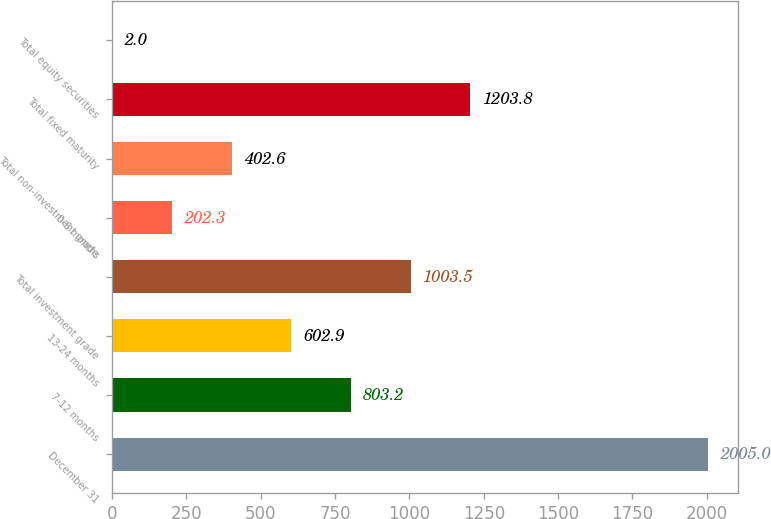<chart> <loc_0><loc_0><loc_500><loc_500><bar_chart><fcel>December 31<fcel>7-12 months<fcel>13-24 months<fcel>Total investment grade<fcel>0-6 months<fcel>Total non-investment grade<fcel>Total fixed maturity<fcel>Total equity securities<nl><fcel>2005<fcel>803.2<fcel>602.9<fcel>1003.5<fcel>202.3<fcel>402.6<fcel>1203.8<fcel>2<nl></chart> 